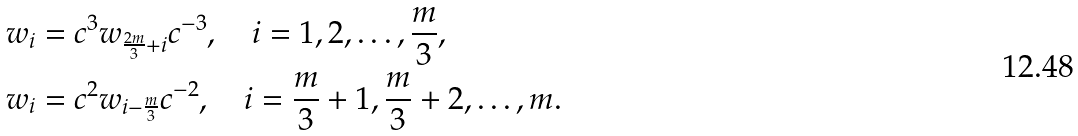<formula> <loc_0><loc_0><loc_500><loc_500>w _ { i } & = c ^ { 3 } w _ { \frac { 2 m } 3 + i } c ^ { - 3 } , \quad i = 1 , 2 , \dots , \frac { m } 3 , \\ w _ { i } & = c ^ { 2 } w _ { i - \frac { m } 3 } c ^ { - 2 } , \quad i = \frac { m } 3 + 1 , \frac { m } 3 + 2 , \dots , m .</formula> 